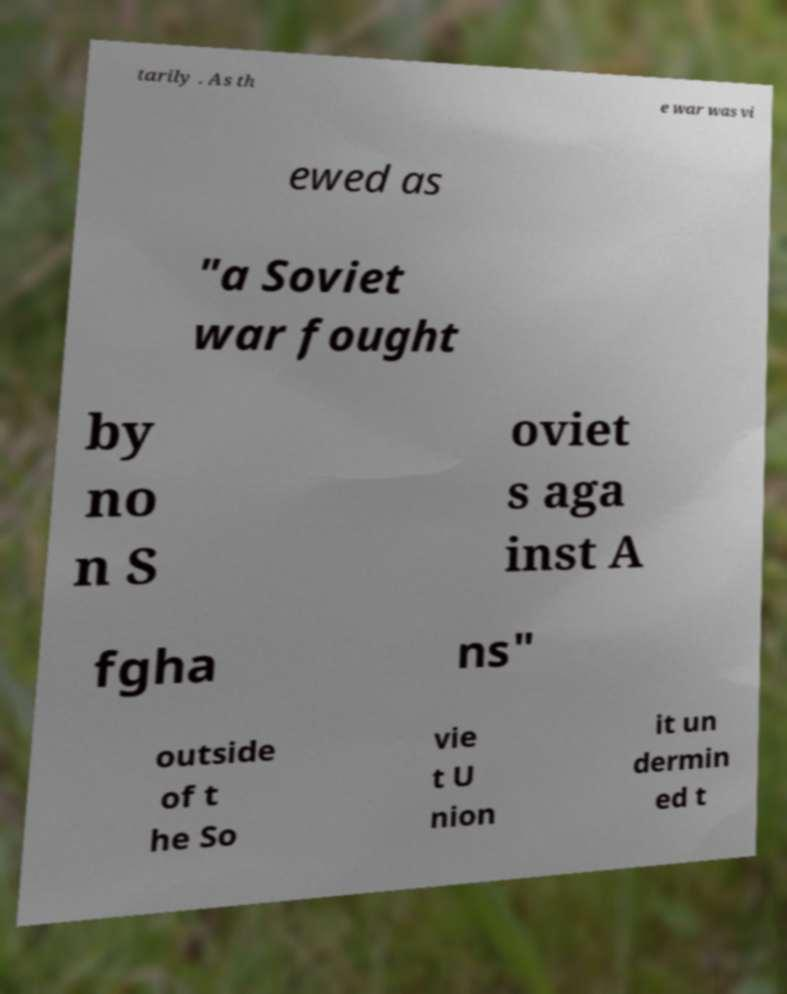Could you assist in decoding the text presented in this image and type it out clearly? tarily . As th e war was vi ewed as "a Soviet war fought by no n S oviet s aga inst A fgha ns" outside of t he So vie t U nion it un dermin ed t 